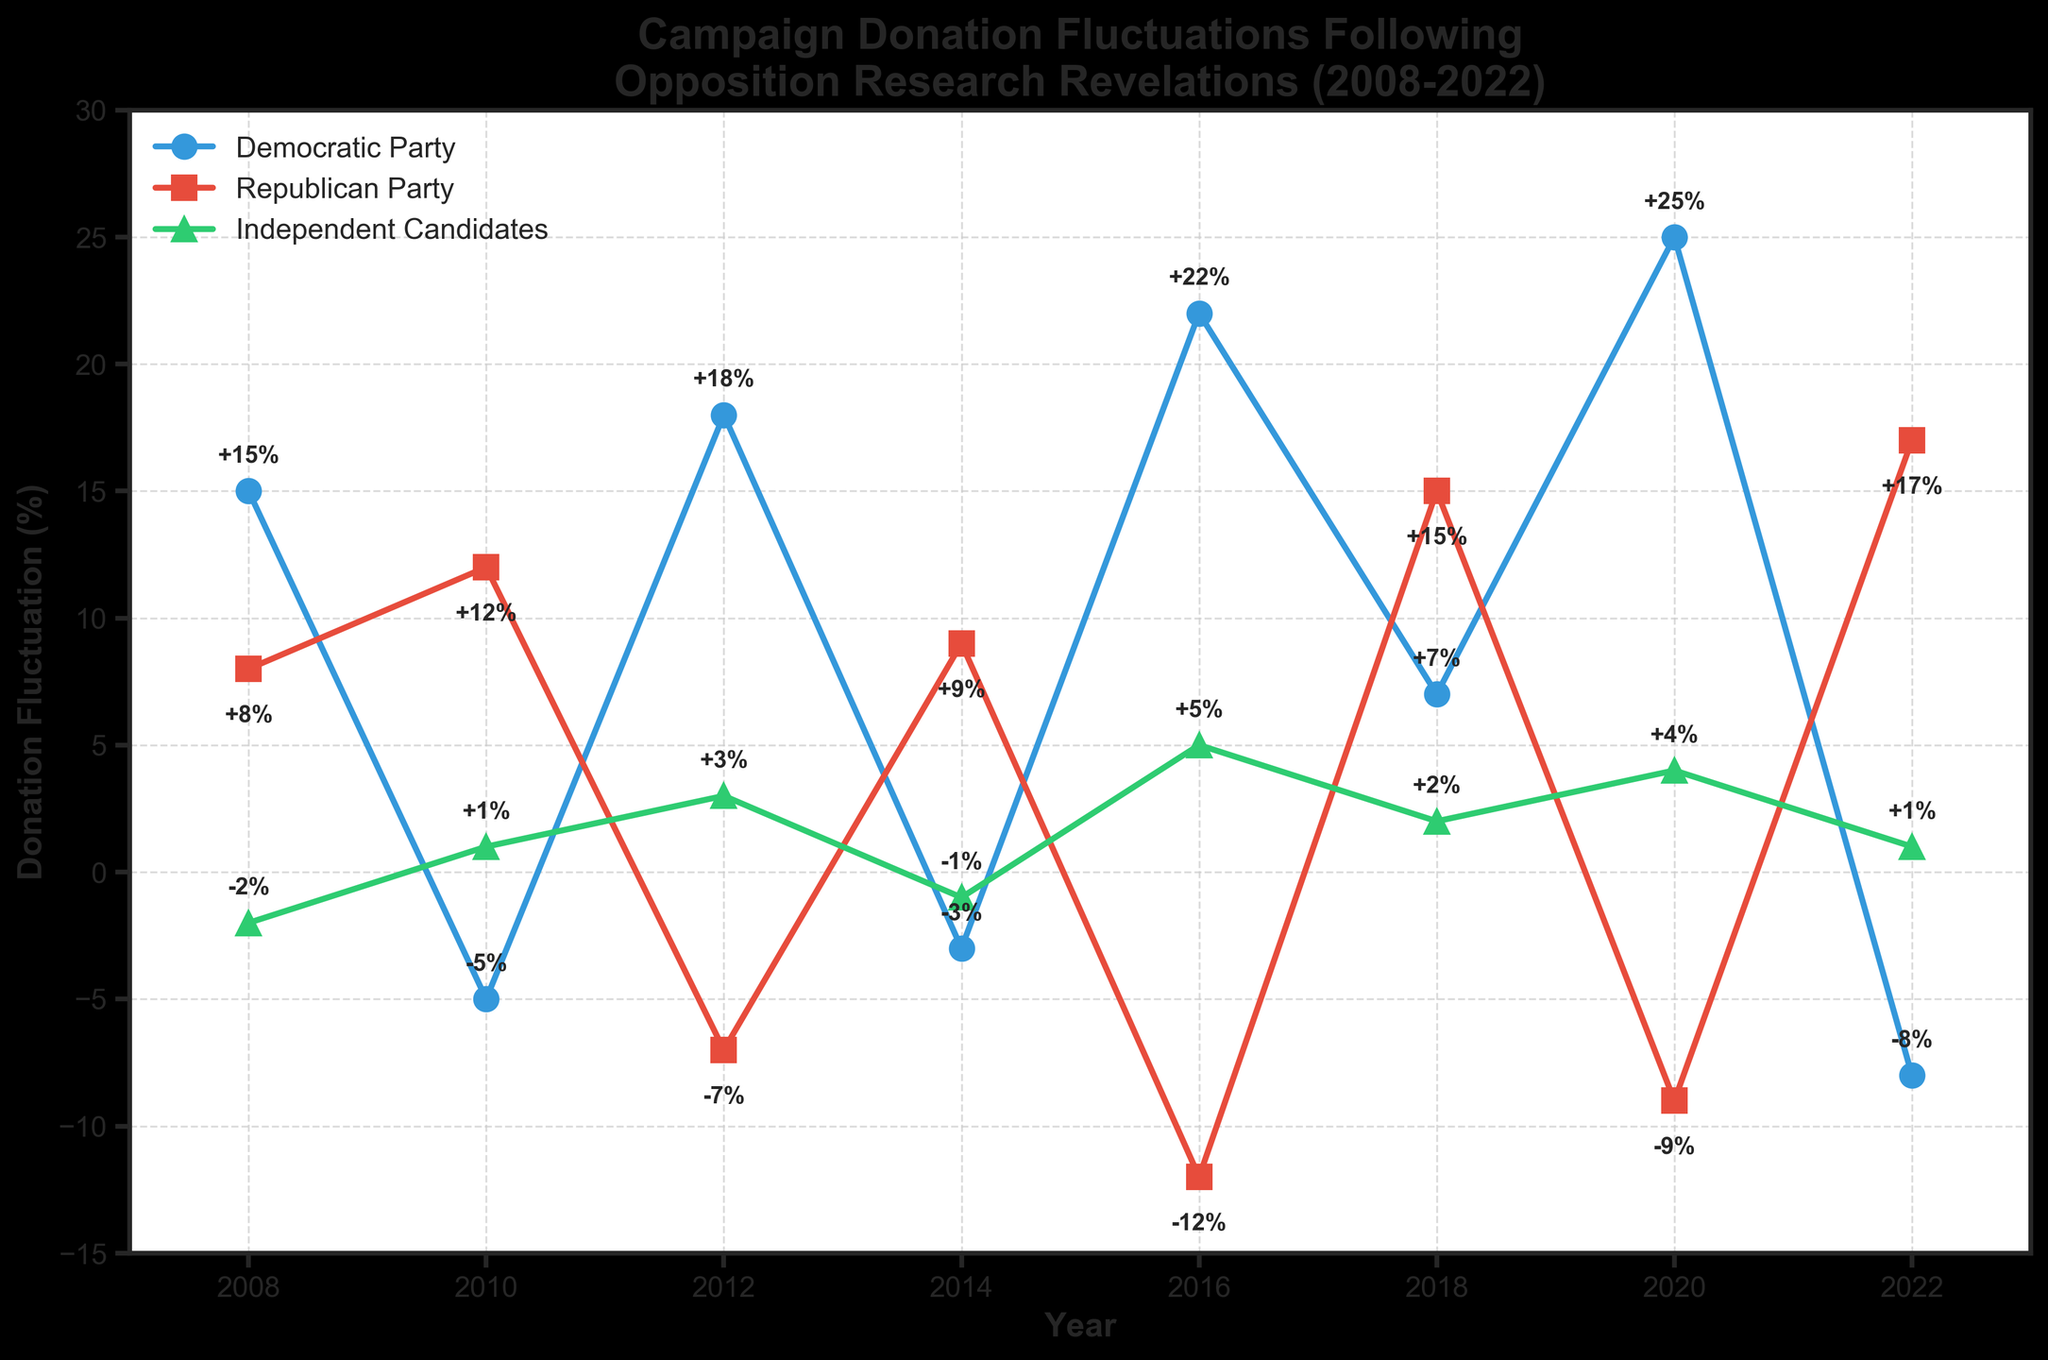What was the biggest increase in donations for the Democratic Party? The figure shows the Democratic Party's fluctuations: +15% (2008), -5% (2010), +18% (2012), -3% (2014), +22% (2016), +7% (2018), +25% (2020), -8% (2022). The biggest increase is +25% in 2020.
Answer: +25% in 2020 What is the difference in donation fluctuations between the Democratic and Republican parties in 2016? The Democratic Party had +22% in 2016, while the Republican Party had -12% in 2016. The difference is 22% - (-12%) = 22% + 12% = 34%.
Answer: 34% How do donations for Independent Candidates in 2012 compare to 2022? In 2012, Independent Candidates had a fluctuation of +3%, and in 2022 they had +1%. Comparing these, +3% is greater than +1%.
Answer: Greater in 2012 by 2% Which party had the most consistent (least variable) donation fluctuations from 2008 to 2022? To determine consistency, compare the range of fluctuations: Democratic (-8% to +25%), Republican (-12% to +17%), Independent (-2% to +5%). Independent Candidates have the smallest range (difference of 7%).
Answer: Independent Candidates What is the average percentage fluctuation in donations for the Republican Party between 2008 and 2022? The Republican Party's fluctuations are +8% (2008), +12% (2010), -7% (2012), +9% (2014), -12% (2016), +15% (2018), -9% (2020), +17% (2022). Summing these up: 8 + 12 + (-7) + 9 + (-12) + 15 + (-9) + 17 = 33. There are 8 data points, so the average is 33 / 8.
Answer: 4.125% Which year saw the highest increase in donations for Independent Candidates? The figure displays Independent Candidates' fluctuations: -2% (2008), +1% (2010), +3% (2012), -1% (2014), +5% (2016), +2% (2018), +4% (2020), +1% (2022). The highest increase is +5% in 2016.
Answer: 2016 In which year did the Democratic Party experience a negative fluctuation in donations? The Democratic Party's negative fluctuations are visible in: 2010 (-5%), 2014 (-3%), and 2022 (-8%).
Answer: 2010, 2014, 2022 Which party had the largest decrease in donation fluctuation in any single year? The Democratic fluctuation ranges from -8% to +25%, the Republican from -12% to +17%, and the Independent from -2% to +5%. The largest decrease is Republican -12% in 2016.
Answer: Republican Party in 2016 What is the sum of the Democratic Party's donation fluctuations in the even-numbered years? The Democratic Party's fluctuations in even-numbered years are +15% (2008), +18% (2012), +22% (2016), +25% (2020). Summing these: 15 + 18 + 22 + 25 = 80.
Answer: 80 